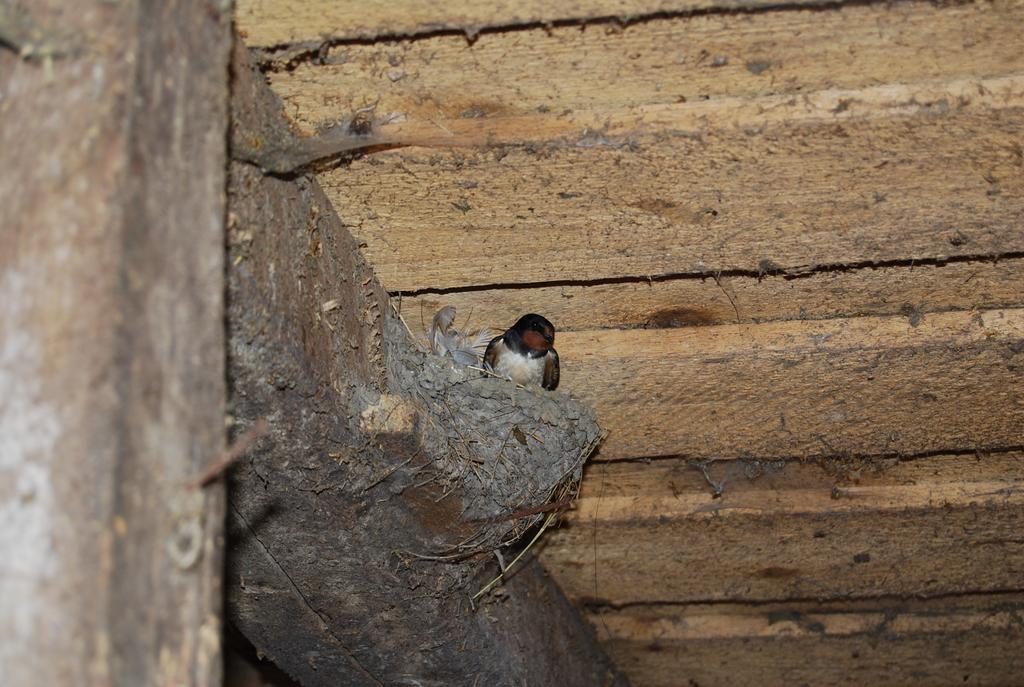Can you describe this image briefly? In this picture there is a bird sitting inside the nest. There is a nest on the wooden roof. 